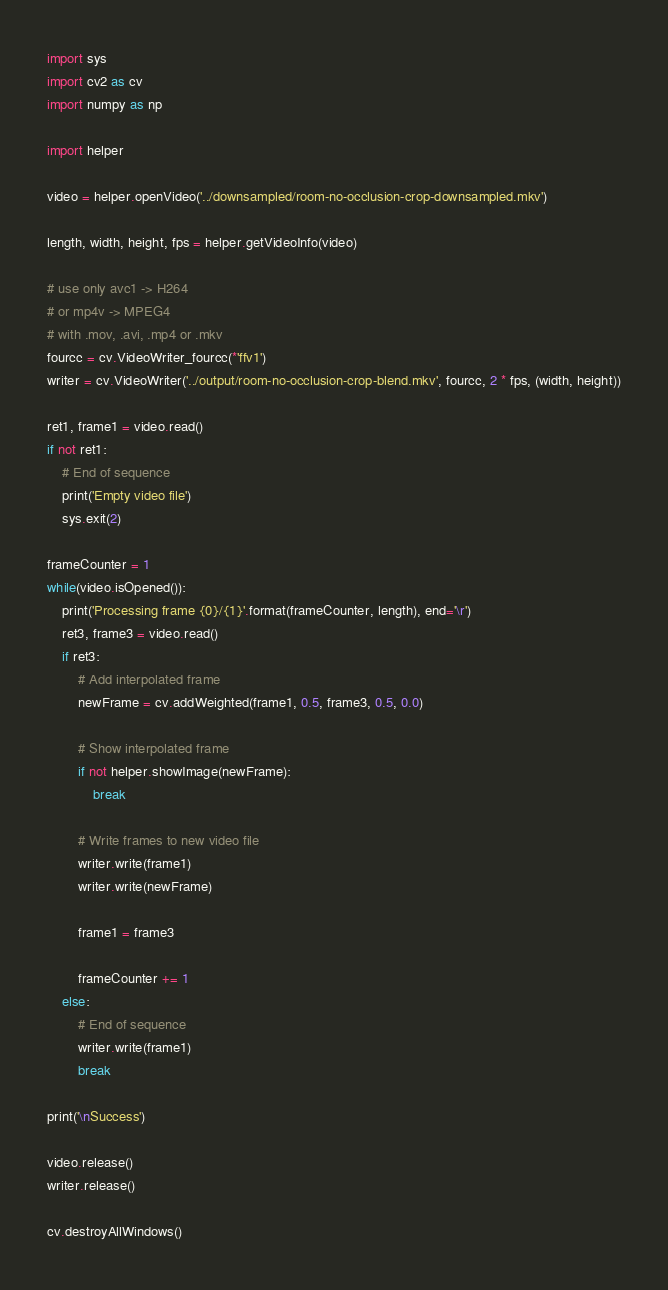<code> <loc_0><loc_0><loc_500><loc_500><_Python_>import sys
import cv2 as cv
import numpy as np

import helper

video = helper.openVideo('../downsampled/room-no-occlusion-crop-downsampled.mkv')

length, width, height, fps = helper.getVideoInfo(video)

# use only avc1 -> H264
# or mp4v -> MPEG4
# with .mov, .avi, .mp4 or .mkv
fourcc = cv.VideoWriter_fourcc(*'ffv1')
writer = cv.VideoWriter('../output/room-no-occlusion-crop-blend.mkv', fourcc, 2 * fps, (width, height))

ret1, frame1 = video.read()
if not ret1:
    # End of sequence
    print('Empty video file')
    sys.exit(2)

frameCounter = 1
while(video.isOpened()):
    print('Processing frame {0}/{1}'.format(frameCounter, length), end='\r')
    ret3, frame3 = video.read()
    if ret3:
        # Add interpolated frame
        newFrame = cv.addWeighted(frame1, 0.5, frame3, 0.5, 0.0)
                    
        # Show interpolated frame
        if not helper.showImage(newFrame):
            break

        # Write frames to new video file
        writer.write(frame1)
        writer.write(newFrame)

        frame1 = frame3

        frameCounter += 1
    else:
        # End of sequence
        writer.write(frame1)
        break

print('\nSuccess')

video.release()
writer.release()

cv.destroyAllWindows()
</code> 